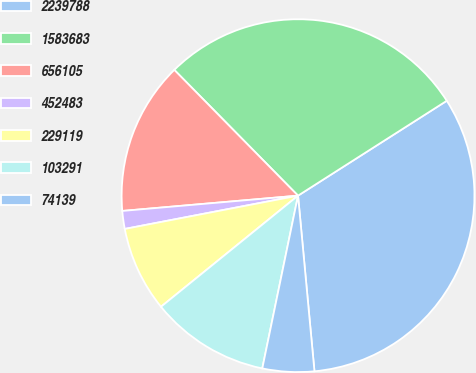Convert chart to OTSL. <chart><loc_0><loc_0><loc_500><loc_500><pie_chart><fcel>2239788<fcel>1583683<fcel>656105<fcel>452483<fcel>229119<fcel>103291<fcel>74139<nl><fcel>32.55%<fcel>28.33%<fcel>14.01%<fcel>1.64%<fcel>7.82%<fcel>10.91%<fcel>4.73%<nl></chart> 